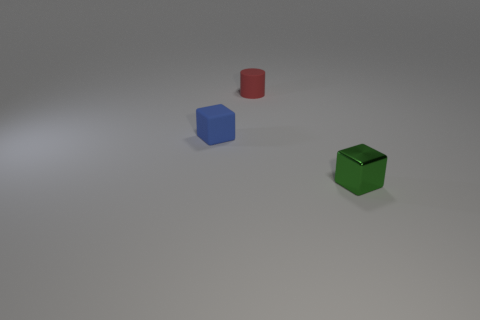Add 1 tiny blue cubes. How many objects exist? 4 Subtract all blocks. How many objects are left? 1 Subtract 0 green balls. How many objects are left? 3 Subtract all tiny metallic blocks. Subtract all cyan cylinders. How many objects are left? 2 Add 2 small rubber cubes. How many small rubber cubes are left? 3 Add 3 small rubber objects. How many small rubber objects exist? 5 